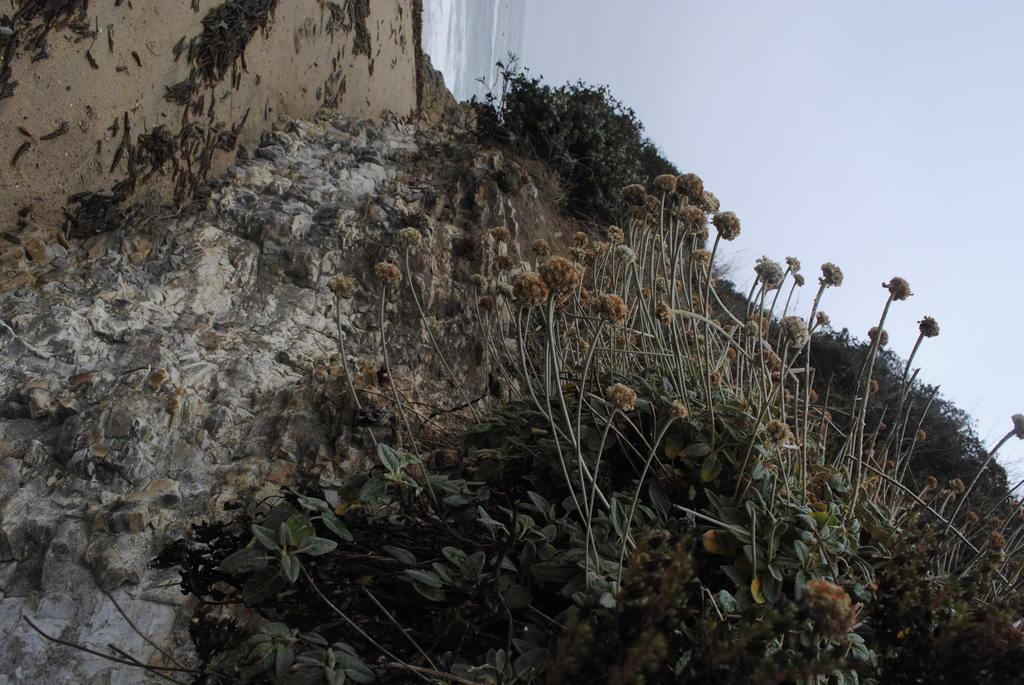What type of living organisms can be seen in the image? Plants and flowers are visible in the image. Where are the plants and flowers located? The plants and flowers are on a rock in the image. What can be seen in the background of the image? The sky is visible in the background of the image. What is the acoustics of the flowers like in the image? The image does not provide information about the acoustics of the flowers, as it is a visual representation and does not include sound. 